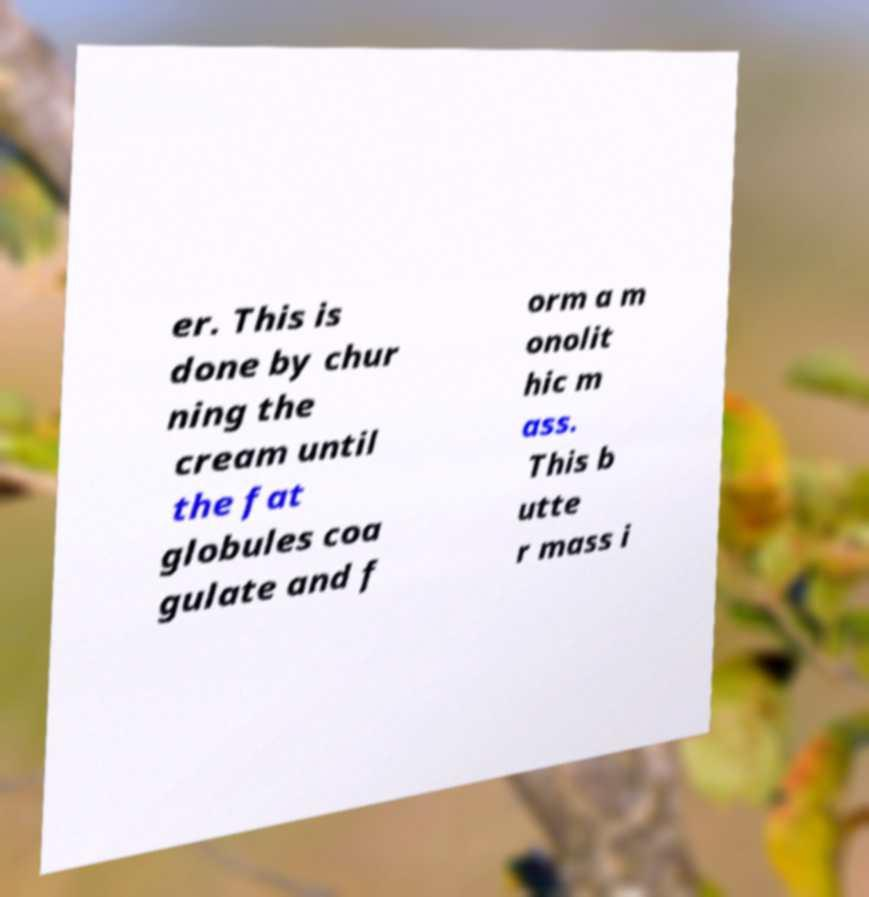What messages or text are displayed in this image? I need them in a readable, typed format. er. This is done by chur ning the cream until the fat globules coa gulate and f orm a m onolit hic m ass. This b utte r mass i 